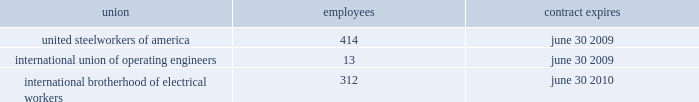Pollutants discharged to waters of the united states and remediation of waters affected by such discharge .
To our knowledge , we are in compliance with all material requirements associated with the various regulations .
The united states congress is actively considering legislation to reduce emissions of greenhouse gases , including carbon dioxide and methane .
In addition , state and regional initiatives to regulate greenhouse gas emissions are underway .
We are monitoring federal and state legislation to assess the potential impact on our operations .
Our most recent calculation of direct greenhouse gas emissions for oneok and oneok partners is estimated to be less than 6 million metric tons of carbon dioxide equivalents on an annual basis .
We will continue efforts to quantify our direct greenhouse gas emissions and will report such emissions as required by any mandatory reporting rule , including the rules anticipated to be issued by the epa in mid-2009 .
Superfund - the comprehensive environmental response , compensation and liability act , also known as cercla or superfund , imposes liability , without regard to fault or the legality of the original act , on certain classes of persons who contributed to the release of a hazardous substance into the environment .
These persons include the owner or operator of a facility where the release occurred and companies that disposed or arranged for the disposal of the hazardous substances found at the facility .
Under cercla , these persons may be liable for the costs of cleaning up the hazardous substances released into the environment , damages to natural resources and the costs of certain health studies .
Chemical site security - the united states department of homeland security ( homeland security ) released an interim rule in april 2007 that requires companies to provide reports on sites where certain chemicals , including many hydrocarbon products , are stored .
We completed the homeland security assessments and our facilities were subsequently assigned to one of four risk-based tiers ranging from high ( tier 1 ) to low ( tier 4 ) risk , or not tiered at all due to low risk .
A majority of our facilities were not tiered .
We are waiting for homeland security 2019s analysis to determine if any of the tiered facilities will require site security plans and possible physical security enhancements .
Climate change - our environmental and climate change strategy focuses on taking steps to minimize the impact of our operations on the environment .
These strategies include : ( i ) developing and maintaining an accurate greenhouse gas emissions inventory , according to rules anticipated to be issued by the epa in mid-2009 ; ( ii ) improving the efficiency of our various pipelines , natural gas processing facilities and natural gas liquids fractionation facilities ; ( iii ) following developing technologies for emission control ; ( iv ) following developing technologies to capture carbon dioxide to keep it from reaching the atmosphere ; and ( v ) analyzing options for future energy investment .
Currently , certain subsidiaries of oneok partners participate in the processing and transmission sectors and ldcs in our distribution segment participate in the distribution sector of the epa 2019s natural gas star program to voluntarily reduce methane emissions .
A subsidiary in our oneok partners 2019 segment was honored in 2008 as the 201cnatural gas star gathering and processing partner of the year 201d for its efforts to positively address environmental issues through voluntary implementation of emission-reduction opportunities .
In addition , we continue to focus on maintaining low rates of lost-and- unaccounted-for methane gas through expanded implementation of best practices to limit the release of methane during pipeline and facility maintenance and operations .
Our most recent calculation of our annual lost-and-unaccounted-for natural gas , for all of our business operations , is less than 1 percent of total throughput .
Employees we employed 4742 people at january 31 , 2009 , including 739 people employed by kansas gas service , who were subject to collective bargaining contracts .
The table sets forth our contracts with collective bargaining units at january 31 , employees contract expires .

As of january 31 , 2009 what percentage of employees were subject to collective bargaining contracts? 
Computations: (739 / 4742)
Answer: 0.15584. 